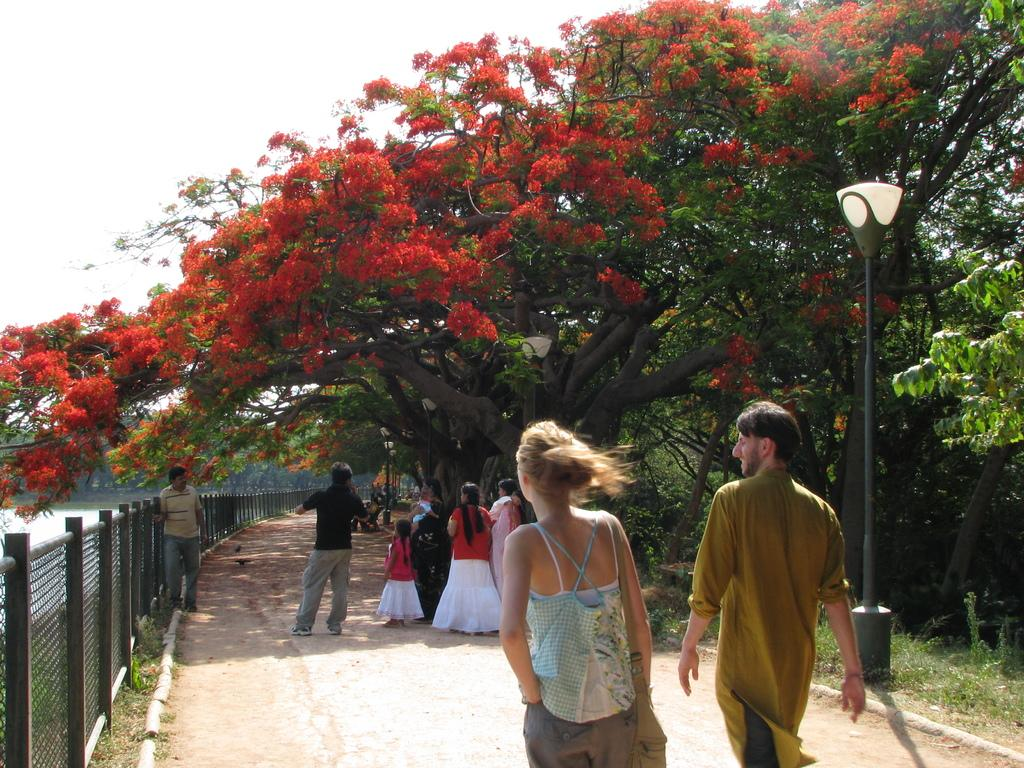What are the people in the image doing? The people in the image are walking on the road. What type of vegetation can be seen in the image? There are flowers, trees, plants, and bushes in the image. What is the purpose of the fence in the image? The purpose of the fence in the image is not specified, but it could be to mark a boundary or provide privacy. What body of water is present in the image? There is a lake in the image. What part of the natural environment is visible in the image? The sky is visible in the image. What is the caption of the image? There is no caption present in the image; it only shows people walking on the road, vegetation, a fence, and a lake. 